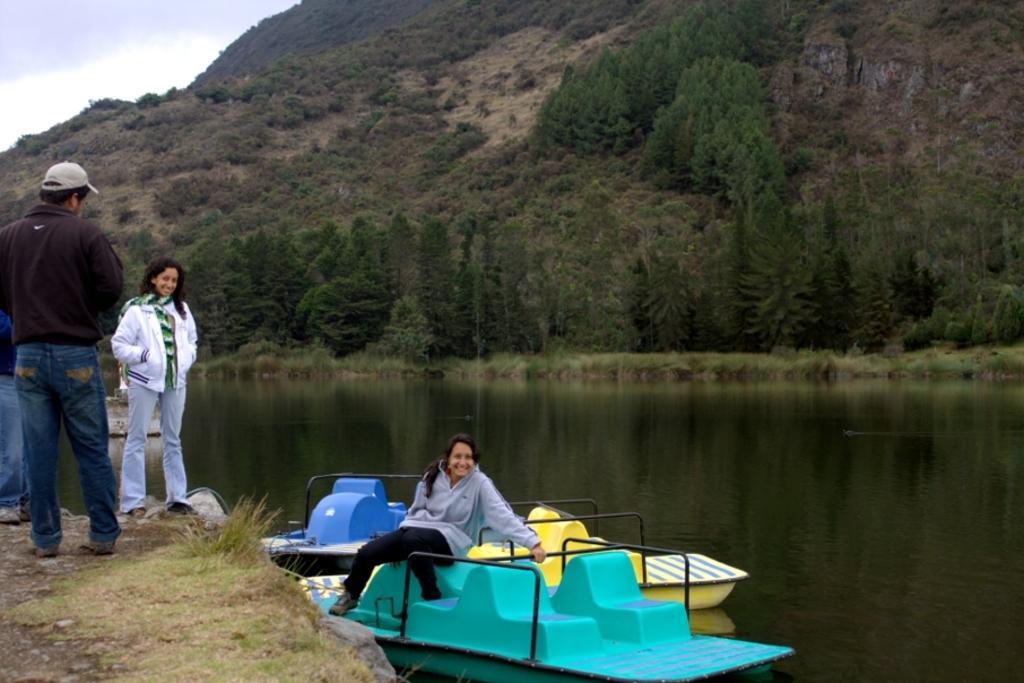In one or two sentences, can you explain what this image depicts? There are three people standing and this woman sitting on a boat and we can see boat above the water. In the background we can see trees,grass,hill and sky. 